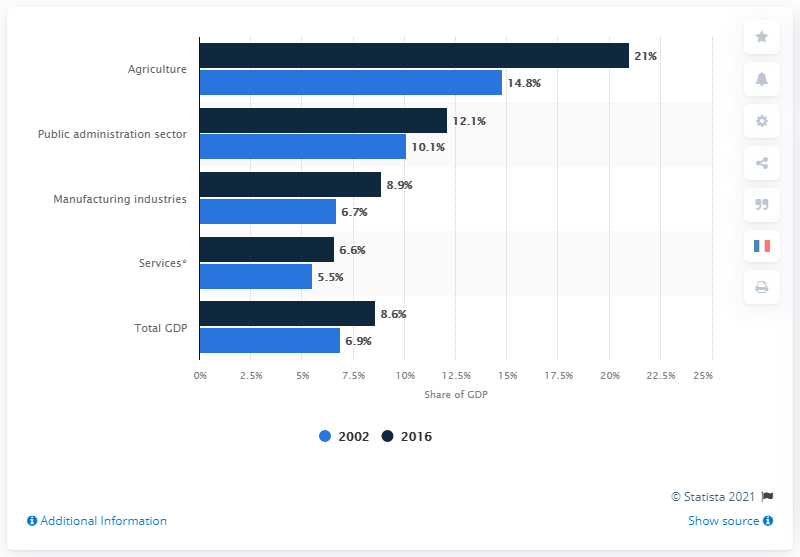Indicate a few pertinent items in this graphic. In the year 2002, the sector with the highest percentage was agriculture. In 2016, the Legal Amazon accounted for approximately 8.6% of Brazil's Gross Domestic Product (GDP). The difference between the total GDP in 2002 and 2016 was 1.7%. 